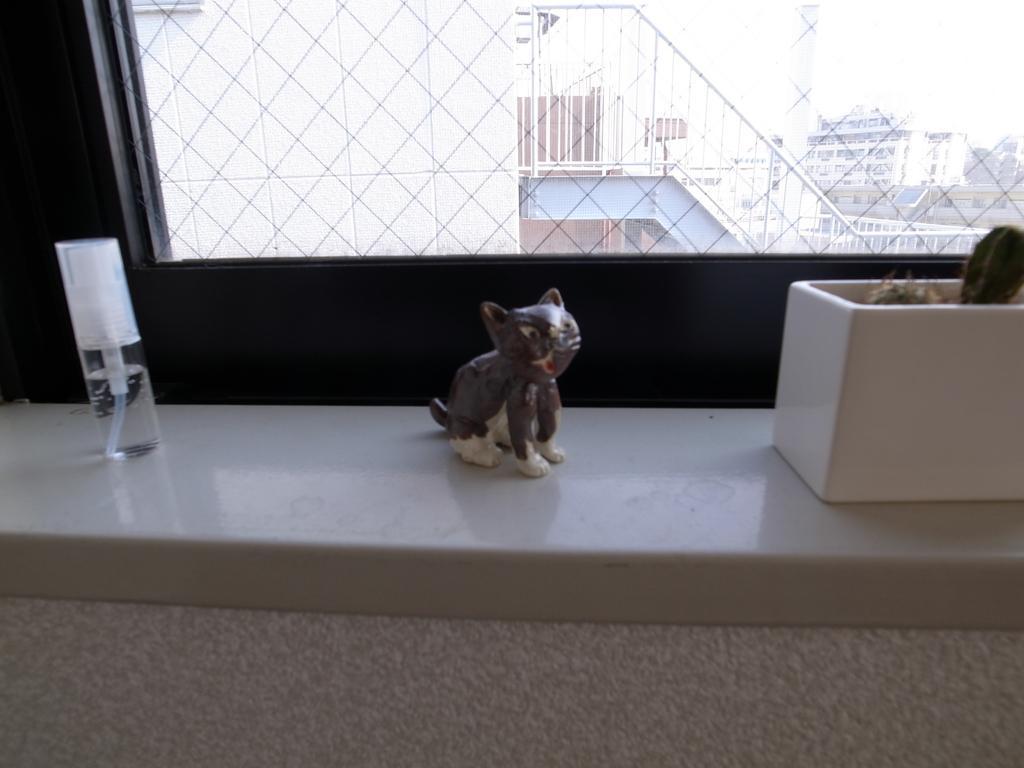Please provide a concise description of this image. On this white surface we can see bottle, statue and plant. Through this window we can see buildings. 